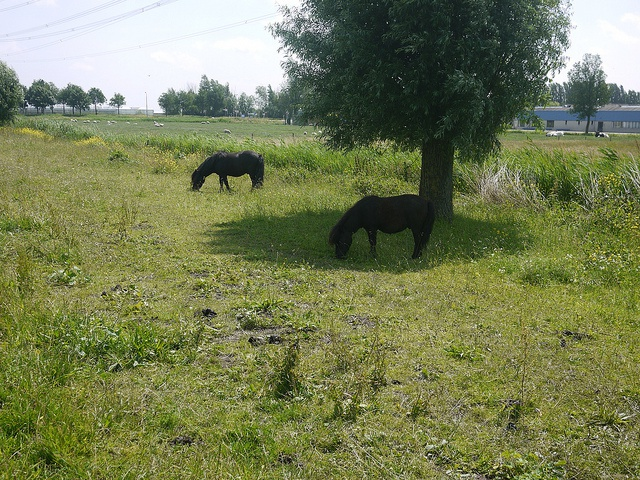Describe the objects in this image and their specific colors. I can see horse in lavender, black, darkgreen, and gray tones and horse in lavender, black, gray, darkgreen, and olive tones in this image. 